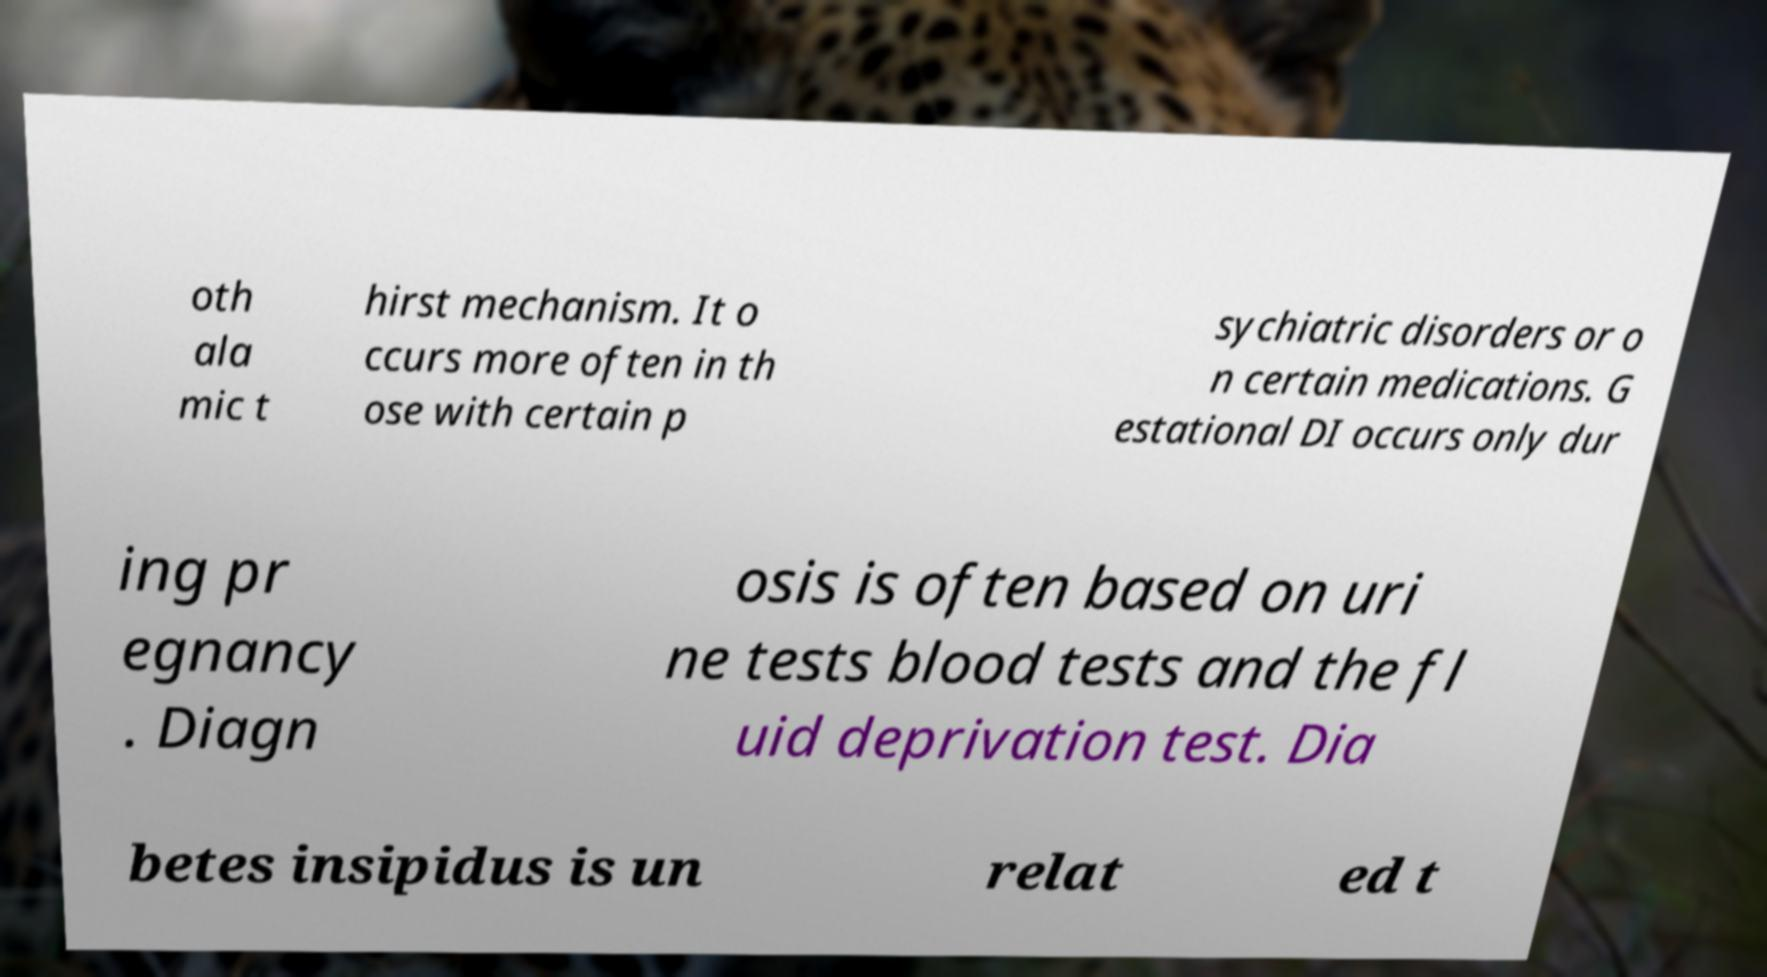What messages or text are displayed in this image? I need them in a readable, typed format. oth ala mic t hirst mechanism. It o ccurs more often in th ose with certain p sychiatric disorders or o n certain medications. G estational DI occurs only dur ing pr egnancy . Diagn osis is often based on uri ne tests blood tests and the fl uid deprivation test. Dia betes insipidus is un relat ed t 